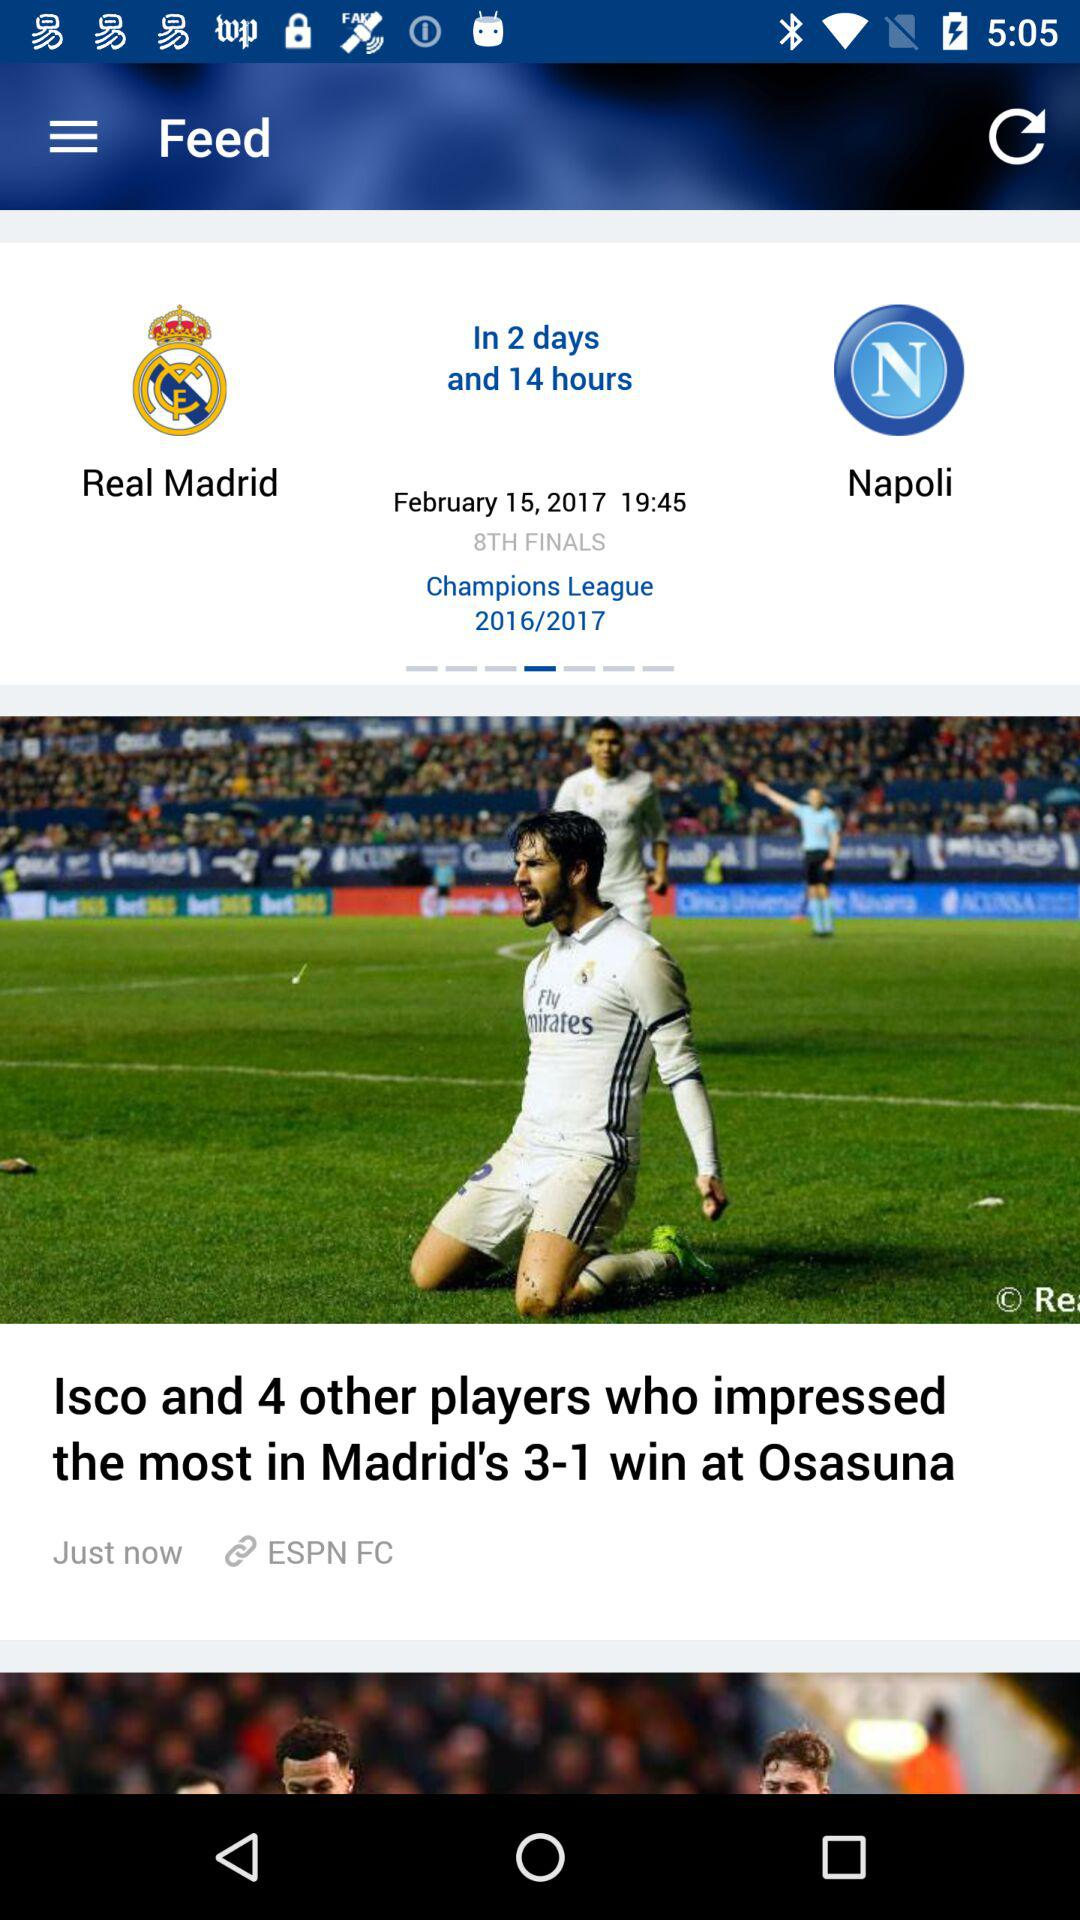How many days until the next game?
Answer the question using a single word or phrase. 2 days 